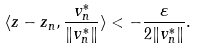Convert formula to latex. <formula><loc_0><loc_0><loc_500><loc_500>\langle z - z _ { n } , \frac { v ^ { * } _ { n } } { \| v ^ { * } _ { n } \| } \rangle < - \frac { \varepsilon } { 2 \| v ^ { * } _ { n } \| } .</formula> 